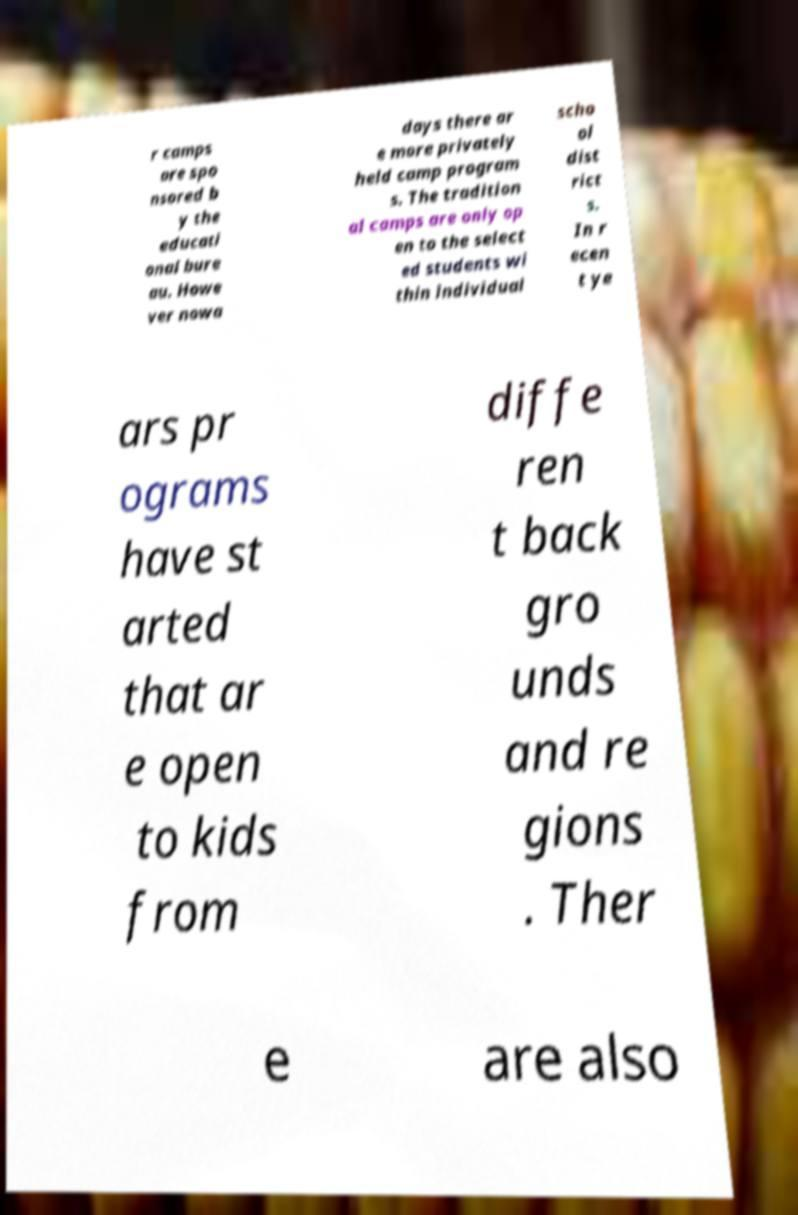Please identify and transcribe the text found in this image. r camps are spo nsored b y the educati onal bure au. Howe ver nowa days there ar e more privately held camp program s. The tradition al camps are only op en to the select ed students wi thin individual scho ol dist rict s. In r ecen t ye ars pr ograms have st arted that ar e open to kids from diffe ren t back gro unds and re gions . Ther e are also 